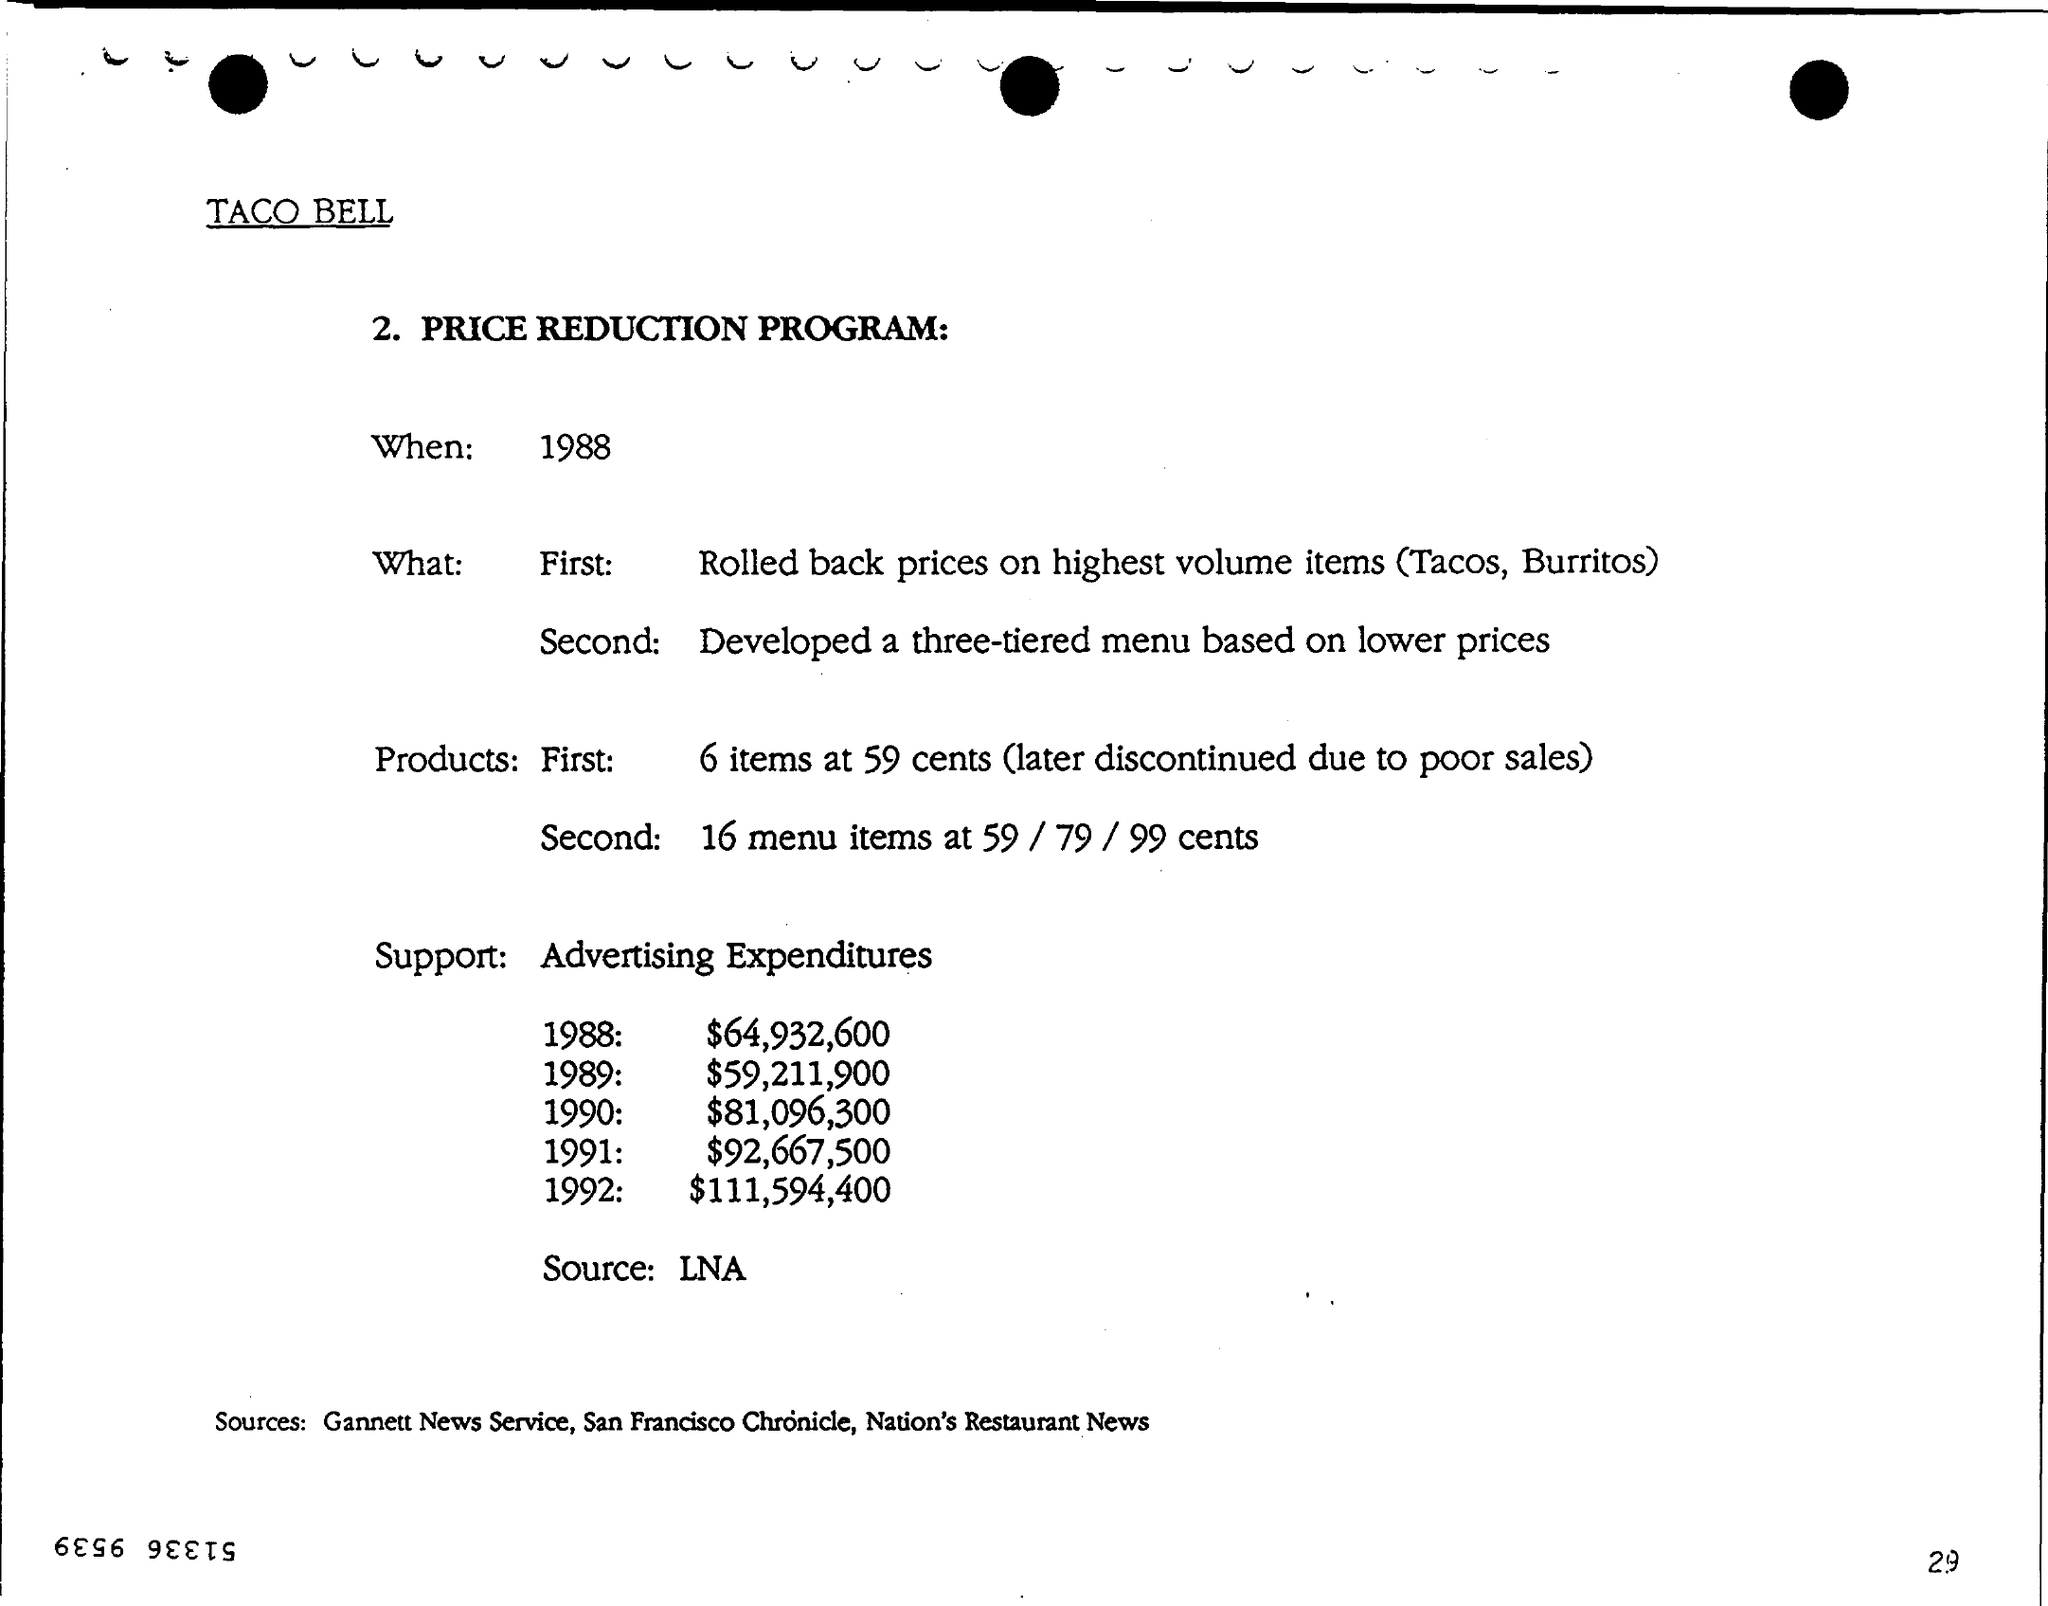What are the sources mentioned? The document credits several sources for its information, including Gannett News Service, San Francisco Chronicle, Nation's Restaurant News, and LNA. These sources appear to have contributed to the data or reporting on the Taco Bell Price Reduction Program. 